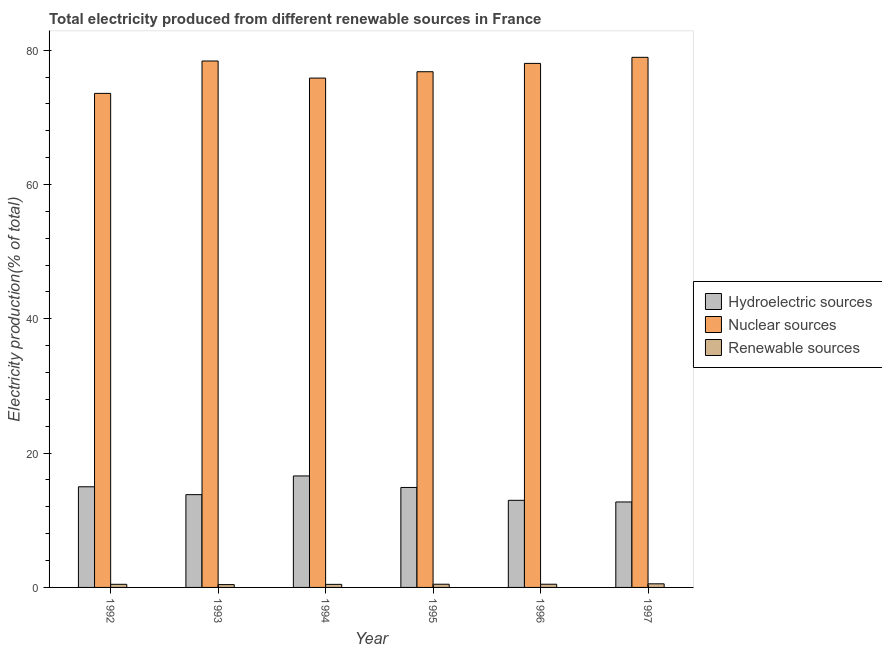How many different coloured bars are there?
Offer a terse response. 3. Are the number of bars per tick equal to the number of legend labels?
Make the answer very short. Yes. Are the number of bars on each tick of the X-axis equal?
Ensure brevity in your answer.  Yes. How many bars are there on the 1st tick from the left?
Ensure brevity in your answer.  3. How many bars are there on the 2nd tick from the right?
Provide a short and direct response. 3. What is the label of the 3rd group of bars from the left?
Offer a terse response. 1994. In how many cases, is the number of bars for a given year not equal to the number of legend labels?
Your response must be concise. 0. What is the percentage of electricity produced by renewable sources in 1992?
Keep it short and to the point. 0.46. Across all years, what is the maximum percentage of electricity produced by hydroelectric sources?
Your answer should be very brief. 16.6. Across all years, what is the minimum percentage of electricity produced by renewable sources?
Provide a short and direct response. 0.42. In which year was the percentage of electricity produced by renewable sources maximum?
Your answer should be very brief. 1997. What is the total percentage of electricity produced by hydroelectric sources in the graph?
Give a very brief answer. 85.99. What is the difference between the percentage of electricity produced by renewable sources in 1993 and that in 1995?
Keep it short and to the point. -0.05. What is the difference between the percentage of electricity produced by renewable sources in 1997 and the percentage of electricity produced by nuclear sources in 1994?
Your answer should be compact. 0.08. What is the average percentage of electricity produced by hydroelectric sources per year?
Provide a succinct answer. 14.33. In the year 1994, what is the difference between the percentage of electricity produced by nuclear sources and percentage of electricity produced by renewable sources?
Give a very brief answer. 0. What is the ratio of the percentage of electricity produced by nuclear sources in 1993 to that in 1994?
Offer a very short reply. 1.03. Is the percentage of electricity produced by nuclear sources in 1992 less than that in 1997?
Offer a terse response. Yes. Is the difference between the percentage of electricity produced by renewable sources in 1992 and 1996 greater than the difference between the percentage of electricity produced by nuclear sources in 1992 and 1996?
Provide a short and direct response. No. What is the difference between the highest and the second highest percentage of electricity produced by hydroelectric sources?
Your response must be concise. 1.61. What is the difference between the highest and the lowest percentage of electricity produced by nuclear sources?
Your response must be concise. 5.37. In how many years, is the percentage of electricity produced by nuclear sources greater than the average percentage of electricity produced by nuclear sources taken over all years?
Offer a terse response. 3. Is the sum of the percentage of electricity produced by renewable sources in 1994 and 1997 greater than the maximum percentage of electricity produced by hydroelectric sources across all years?
Ensure brevity in your answer.  Yes. What does the 3rd bar from the left in 1992 represents?
Offer a very short reply. Renewable sources. What does the 1st bar from the right in 1995 represents?
Ensure brevity in your answer.  Renewable sources. How many years are there in the graph?
Provide a succinct answer. 6. Are the values on the major ticks of Y-axis written in scientific E-notation?
Provide a succinct answer. No. Does the graph contain any zero values?
Give a very brief answer. No. Does the graph contain grids?
Your answer should be compact. No. How are the legend labels stacked?
Provide a succinct answer. Vertical. What is the title of the graph?
Ensure brevity in your answer.  Total electricity produced from different renewable sources in France. Does "Methane" appear as one of the legend labels in the graph?
Provide a short and direct response. No. What is the label or title of the X-axis?
Keep it short and to the point. Year. What is the Electricity production(% of total) of Hydroelectric sources in 1992?
Ensure brevity in your answer.  14.99. What is the Electricity production(% of total) of Nuclear sources in 1992?
Make the answer very short. 73.57. What is the Electricity production(% of total) in Renewable sources in 1992?
Your answer should be compact. 0.46. What is the Electricity production(% of total) of Hydroelectric sources in 1993?
Provide a succinct answer. 13.82. What is the Electricity production(% of total) of Nuclear sources in 1993?
Provide a short and direct response. 78.4. What is the Electricity production(% of total) of Renewable sources in 1993?
Your answer should be compact. 0.42. What is the Electricity production(% of total) in Hydroelectric sources in 1994?
Your answer should be very brief. 16.6. What is the Electricity production(% of total) of Nuclear sources in 1994?
Give a very brief answer. 75.85. What is the Electricity production(% of total) in Renewable sources in 1994?
Offer a very short reply. 0.46. What is the Electricity production(% of total) of Hydroelectric sources in 1995?
Ensure brevity in your answer.  14.89. What is the Electricity production(% of total) in Nuclear sources in 1995?
Make the answer very short. 76.8. What is the Electricity production(% of total) of Renewable sources in 1995?
Provide a short and direct response. 0.48. What is the Electricity production(% of total) of Hydroelectric sources in 1996?
Provide a short and direct response. 12.97. What is the Electricity production(% of total) of Nuclear sources in 1996?
Keep it short and to the point. 78.04. What is the Electricity production(% of total) in Renewable sources in 1996?
Keep it short and to the point. 0.48. What is the Electricity production(% of total) in Hydroelectric sources in 1997?
Provide a succinct answer. 12.73. What is the Electricity production(% of total) of Nuclear sources in 1997?
Keep it short and to the point. 78.94. What is the Electricity production(% of total) in Renewable sources in 1997?
Your response must be concise. 0.54. Across all years, what is the maximum Electricity production(% of total) of Hydroelectric sources?
Ensure brevity in your answer.  16.6. Across all years, what is the maximum Electricity production(% of total) in Nuclear sources?
Make the answer very short. 78.94. Across all years, what is the maximum Electricity production(% of total) in Renewable sources?
Ensure brevity in your answer.  0.54. Across all years, what is the minimum Electricity production(% of total) in Hydroelectric sources?
Provide a succinct answer. 12.73. Across all years, what is the minimum Electricity production(% of total) of Nuclear sources?
Your answer should be compact. 73.57. Across all years, what is the minimum Electricity production(% of total) in Renewable sources?
Your answer should be very brief. 0.42. What is the total Electricity production(% of total) of Hydroelectric sources in the graph?
Your answer should be very brief. 86. What is the total Electricity production(% of total) in Nuclear sources in the graph?
Your answer should be compact. 461.6. What is the total Electricity production(% of total) in Renewable sources in the graph?
Your response must be concise. 2.83. What is the difference between the Electricity production(% of total) in Hydroelectric sources in 1992 and that in 1993?
Ensure brevity in your answer.  1.17. What is the difference between the Electricity production(% of total) in Nuclear sources in 1992 and that in 1993?
Your response must be concise. -4.82. What is the difference between the Electricity production(% of total) in Renewable sources in 1992 and that in 1993?
Your answer should be very brief. 0.04. What is the difference between the Electricity production(% of total) of Hydroelectric sources in 1992 and that in 1994?
Ensure brevity in your answer.  -1.61. What is the difference between the Electricity production(% of total) of Nuclear sources in 1992 and that in 1994?
Give a very brief answer. -2.28. What is the difference between the Electricity production(% of total) of Renewable sources in 1992 and that in 1994?
Provide a short and direct response. 0.01. What is the difference between the Electricity production(% of total) of Hydroelectric sources in 1992 and that in 1995?
Ensure brevity in your answer.  0.1. What is the difference between the Electricity production(% of total) in Nuclear sources in 1992 and that in 1995?
Provide a short and direct response. -3.22. What is the difference between the Electricity production(% of total) of Renewable sources in 1992 and that in 1995?
Your answer should be very brief. -0.01. What is the difference between the Electricity production(% of total) in Hydroelectric sources in 1992 and that in 1996?
Offer a very short reply. 2.02. What is the difference between the Electricity production(% of total) in Nuclear sources in 1992 and that in 1996?
Provide a short and direct response. -4.47. What is the difference between the Electricity production(% of total) of Renewable sources in 1992 and that in 1996?
Ensure brevity in your answer.  -0.01. What is the difference between the Electricity production(% of total) in Hydroelectric sources in 1992 and that in 1997?
Ensure brevity in your answer.  2.26. What is the difference between the Electricity production(% of total) in Nuclear sources in 1992 and that in 1997?
Your answer should be compact. -5.37. What is the difference between the Electricity production(% of total) of Renewable sources in 1992 and that in 1997?
Your answer should be compact. -0.07. What is the difference between the Electricity production(% of total) of Hydroelectric sources in 1993 and that in 1994?
Make the answer very short. -2.78. What is the difference between the Electricity production(% of total) of Nuclear sources in 1993 and that in 1994?
Your response must be concise. 2.55. What is the difference between the Electricity production(% of total) of Renewable sources in 1993 and that in 1994?
Make the answer very short. -0.04. What is the difference between the Electricity production(% of total) of Hydroelectric sources in 1993 and that in 1995?
Make the answer very short. -1.07. What is the difference between the Electricity production(% of total) in Nuclear sources in 1993 and that in 1995?
Offer a terse response. 1.6. What is the difference between the Electricity production(% of total) in Renewable sources in 1993 and that in 1995?
Your response must be concise. -0.05. What is the difference between the Electricity production(% of total) in Hydroelectric sources in 1993 and that in 1996?
Ensure brevity in your answer.  0.85. What is the difference between the Electricity production(% of total) of Nuclear sources in 1993 and that in 1996?
Keep it short and to the point. 0.36. What is the difference between the Electricity production(% of total) of Renewable sources in 1993 and that in 1996?
Keep it short and to the point. -0.06. What is the difference between the Electricity production(% of total) in Hydroelectric sources in 1993 and that in 1997?
Keep it short and to the point. 1.09. What is the difference between the Electricity production(% of total) in Nuclear sources in 1993 and that in 1997?
Your response must be concise. -0.55. What is the difference between the Electricity production(% of total) in Renewable sources in 1993 and that in 1997?
Give a very brief answer. -0.12. What is the difference between the Electricity production(% of total) of Hydroelectric sources in 1994 and that in 1995?
Offer a terse response. 1.72. What is the difference between the Electricity production(% of total) in Nuclear sources in 1994 and that in 1995?
Your response must be concise. -0.95. What is the difference between the Electricity production(% of total) in Renewable sources in 1994 and that in 1995?
Offer a terse response. -0.02. What is the difference between the Electricity production(% of total) in Hydroelectric sources in 1994 and that in 1996?
Give a very brief answer. 3.63. What is the difference between the Electricity production(% of total) of Nuclear sources in 1994 and that in 1996?
Offer a terse response. -2.19. What is the difference between the Electricity production(% of total) of Renewable sources in 1994 and that in 1996?
Keep it short and to the point. -0.02. What is the difference between the Electricity production(% of total) in Hydroelectric sources in 1994 and that in 1997?
Your answer should be compact. 3.87. What is the difference between the Electricity production(% of total) in Nuclear sources in 1994 and that in 1997?
Your response must be concise. -3.09. What is the difference between the Electricity production(% of total) in Renewable sources in 1994 and that in 1997?
Keep it short and to the point. -0.08. What is the difference between the Electricity production(% of total) in Hydroelectric sources in 1995 and that in 1996?
Offer a terse response. 1.91. What is the difference between the Electricity production(% of total) of Nuclear sources in 1995 and that in 1996?
Your answer should be compact. -1.24. What is the difference between the Electricity production(% of total) in Renewable sources in 1995 and that in 1996?
Give a very brief answer. -0. What is the difference between the Electricity production(% of total) of Hydroelectric sources in 1995 and that in 1997?
Provide a succinct answer. 2.16. What is the difference between the Electricity production(% of total) of Nuclear sources in 1995 and that in 1997?
Give a very brief answer. -2.14. What is the difference between the Electricity production(% of total) of Renewable sources in 1995 and that in 1997?
Keep it short and to the point. -0.06. What is the difference between the Electricity production(% of total) of Hydroelectric sources in 1996 and that in 1997?
Offer a very short reply. 0.24. What is the difference between the Electricity production(% of total) in Nuclear sources in 1996 and that in 1997?
Provide a short and direct response. -0.9. What is the difference between the Electricity production(% of total) of Renewable sources in 1996 and that in 1997?
Offer a very short reply. -0.06. What is the difference between the Electricity production(% of total) of Hydroelectric sources in 1992 and the Electricity production(% of total) of Nuclear sources in 1993?
Your response must be concise. -63.41. What is the difference between the Electricity production(% of total) of Hydroelectric sources in 1992 and the Electricity production(% of total) of Renewable sources in 1993?
Offer a very short reply. 14.57. What is the difference between the Electricity production(% of total) of Nuclear sources in 1992 and the Electricity production(% of total) of Renewable sources in 1993?
Keep it short and to the point. 73.15. What is the difference between the Electricity production(% of total) of Hydroelectric sources in 1992 and the Electricity production(% of total) of Nuclear sources in 1994?
Your answer should be very brief. -60.86. What is the difference between the Electricity production(% of total) of Hydroelectric sources in 1992 and the Electricity production(% of total) of Renewable sources in 1994?
Give a very brief answer. 14.53. What is the difference between the Electricity production(% of total) of Nuclear sources in 1992 and the Electricity production(% of total) of Renewable sources in 1994?
Offer a very short reply. 73.12. What is the difference between the Electricity production(% of total) of Hydroelectric sources in 1992 and the Electricity production(% of total) of Nuclear sources in 1995?
Offer a very short reply. -61.81. What is the difference between the Electricity production(% of total) in Hydroelectric sources in 1992 and the Electricity production(% of total) in Renewable sources in 1995?
Keep it short and to the point. 14.51. What is the difference between the Electricity production(% of total) in Nuclear sources in 1992 and the Electricity production(% of total) in Renewable sources in 1995?
Provide a succinct answer. 73.1. What is the difference between the Electricity production(% of total) in Hydroelectric sources in 1992 and the Electricity production(% of total) in Nuclear sources in 1996?
Provide a succinct answer. -63.05. What is the difference between the Electricity production(% of total) in Hydroelectric sources in 1992 and the Electricity production(% of total) in Renewable sources in 1996?
Your response must be concise. 14.51. What is the difference between the Electricity production(% of total) in Nuclear sources in 1992 and the Electricity production(% of total) in Renewable sources in 1996?
Make the answer very short. 73.1. What is the difference between the Electricity production(% of total) of Hydroelectric sources in 1992 and the Electricity production(% of total) of Nuclear sources in 1997?
Make the answer very short. -63.95. What is the difference between the Electricity production(% of total) in Hydroelectric sources in 1992 and the Electricity production(% of total) in Renewable sources in 1997?
Offer a terse response. 14.45. What is the difference between the Electricity production(% of total) of Nuclear sources in 1992 and the Electricity production(% of total) of Renewable sources in 1997?
Keep it short and to the point. 73.04. What is the difference between the Electricity production(% of total) of Hydroelectric sources in 1993 and the Electricity production(% of total) of Nuclear sources in 1994?
Your answer should be compact. -62.03. What is the difference between the Electricity production(% of total) in Hydroelectric sources in 1993 and the Electricity production(% of total) in Renewable sources in 1994?
Provide a short and direct response. 13.36. What is the difference between the Electricity production(% of total) in Nuclear sources in 1993 and the Electricity production(% of total) in Renewable sources in 1994?
Provide a short and direct response. 77.94. What is the difference between the Electricity production(% of total) in Hydroelectric sources in 1993 and the Electricity production(% of total) in Nuclear sources in 1995?
Provide a short and direct response. -62.98. What is the difference between the Electricity production(% of total) in Hydroelectric sources in 1993 and the Electricity production(% of total) in Renewable sources in 1995?
Keep it short and to the point. 13.34. What is the difference between the Electricity production(% of total) in Nuclear sources in 1993 and the Electricity production(% of total) in Renewable sources in 1995?
Offer a terse response. 77.92. What is the difference between the Electricity production(% of total) of Hydroelectric sources in 1993 and the Electricity production(% of total) of Nuclear sources in 1996?
Your answer should be very brief. -64.22. What is the difference between the Electricity production(% of total) in Hydroelectric sources in 1993 and the Electricity production(% of total) in Renewable sources in 1996?
Your answer should be compact. 13.34. What is the difference between the Electricity production(% of total) in Nuclear sources in 1993 and the Electricity production(% of total) in Renewable sources in 1996?
Offer a very short reply. 77.92. What is the difference between the Electricity production(% of total) of Hydroelectric sources in 1993 and the Electricity production(% of total) of Nuclear sources in 1997?
Offer a very short reply. -65.12. What is the difference between the Electricity production(% of total) of Hydroelectric sources in 1993 and the Electricity production(% of total) of Renewable sources in 1997?
Provide a succinct answer. 13.28. What is the difference between the Electricity production(% of total) of Nuclear sources in 1993 and the Electricity production(% of total) of Renewable sources in 1997?
Give a very brief answer. 77.86. What is the difference between the Electricity production(% of total) of Hydroelectric sources in 1994 and the Electricity production(% of total) of Nuclear sources in 1995?
Keep it short and to the point. -60.2. What is the difference between the Electricity production(% of total) of Hydroelectric sources in 1994 and the Electricity production(% of total) of Renewable sources in 1995?
Your answer should be compact. 16.13. What is the difference between the Electricity production(% of total) in Nuclear sources in 1994 and the Electricity production(% of total) in Renewable sources in 1995?
Your response must be concise. 75.38. What is the difference between the Electricity production(% of total) in Hydroelectric sources in 1994 and the Electricity production(% of total) in Nuclear sources in 1996?
Your response must be concise. -61.44. What is the difference between the Electricity production(% of total) of Hydroelectric sources in 1994 and the Electricity production(% of total) of Renewable sources in 1996?
Your response must be concise. 16.12. What is the difference between the Electricity production(% of total) in Nuclear sources in 1994 and the Electricity production(% of total) in Renewable sources in 1996?
Provide a short and direct response. 75.37. What is the difference between the Electricity production(% of total) of Hydroelectric sources in 1994 and the Electricity production(% of total) of Nuclear sources in 1997?
Offer a terse response. -62.34. What is the difference between the Electricity production(% of total) of Hydroelectric sources in 1994 and the Electricity production(% of total) of Renewable sources in 1997?
Keep it short and to the point. 16.07. What is the difference between the Electricity production(% of total) in Nuclear sources in 1994 and the Electricity production(% of total) in Renewable sources in 1997?
Your answer should be compact. 75.31. What is the difference between the Electricity production(% of total) in Hydroelectric sources in 1995 and the Electricity production(% of total) in Nuclear sources in 1996?
Your answer should be compact. -63.15. What is the difference between the Electricity production(% of total) of Hydroelectric sources in 1995 and the Electricity production(% of total) of Renewable sources in 1996?
Provide a short and direct response. 14.41. What is the difference between the Electricity production(% of total) of Nuclear sources in 1995 and the Electricity production(% of total) of Renewable sources in 1996?
Keep it short and to the point. 76.32. What is the difference between the Electricity production(% of total) of Hydroelectric sources in 1995 and the Electricity production(% of total) of Nuclear sources in 1997?
Offer a terse response. -64.06. What is the difference between the Electricity production(% of total) of Hydroelectric sources in 1995 and the Electricity production(% of total) of Renewable sources in 1997?
Give a very brief answer. 14.35. What is the difference between the Electricity production(% of total) in Nuclear sources in 1995 and the Electricity production(% of total) in Renewable sources in 1997?
Provide a succinct answer. 76.26. What is the difference between the Electricity production(% of total) of Hydroelectric sources in 1996 and the Electricity production(% of total) of Nuclear sources in 1997?
Ensure brevity in your answer.  -65.97. What is the difference between the Electricity production(% of total) in Hydroelectric sources in 1996 and the Electricity production(% of total) in Renewable sources in 1997?
Provide a succinct answer. 12.43. What is the difference between the Electricity production(% of total) in Nuclear sources in 1996 and the Electricity production(% of total) in Renewable sources in 1997?
Provide a short and direct response. 77.5. What is the average Electricity production(% of total) of Hydroelectric sources per year?
Give a very brief answer. 14.33. What is the average Electricity production(% of total) in Nuclear sources per year?
Provide a short and direct response. 76.93. What is the average Electricity production(% of total) in Renewable sources per year?
Provide a succinct answer. 0.47. In the year 1992, what is the difference between the Electricity production(% of total) in Hydroelectric sources and Electricity production(% of total) in Nuclear sources?
Your answer should be very brief. -58.58. In the year 1992, what is the difference between the Electricity production(% of total) of Hydroelectric sources and Electricity production(% of total) of Renewable sources?
Make the answer very short. 14.53. In the year 1992, what is the difference between the Electricity production(% of total) of Nuclear sources and Electricity production(% of total) of Renewable sources?
Provide a succinct answer. 73.11. In the year 1993, what is the difference between the Electricity production(% of total) of Hydroelectric sources and Electricity production(% of total) of Nuclear sources?
Provide a succinct answer. -64.58. In the year 1993, what is the difference between the Electricity production(% of total) in Hydroelectric sources and Electricity production(% of total) in Renewable sources?
Offer a very short reply. 13.4. In the year 1993, what is the difference between the Electricity production(% of total) of Nuclear sources and Electricity production(% of total) of Renewable sources?
Offer a very short reply. 77.97. In the year 1994, what is the difference between the Electricity production(% of total) of Hydroelectric sources and Electricity production(% of total) of Nuclear sources?
Your answer should be very brief. -59.25. In the year 1994, what is the difference between the Electricity production(% of total) of Hydroelectric sources and Electricity production(% of total) of Renewable sources?
Offer a very short reply. 16.15. In the year 1994, what is the difference between the Electricity production(% of total) of Nuclear sources and Electricity production(% of total) of Renewable sources?
Your answer should be compact. 75.39. In the year 1995, what is the difference between the Electricity production(% of total) in Hydroelectric sources and Electricity production(% of total) in Nuclear sources?
Offer a terse response. -61.91. In the year 1995, what is the difference between the Electricity production(% of total) of Hydroelectric sources and Electricity production(% of total) of Renewable sources?
Make the answer very short. 14.41. In the year 1995, what is the difference between the Electricity production(% of total) of Nuclear sources and Electricity production(% of total) of Renewable sources?
Keep it short and to the point. 76.32. In the year 1996, what is the difference between the Electricity production(% of total) of Hydroelectric sources and Electricity production(% of total) of Nuclear sources?
Your answer should be compact. -65.07. In the year 1996, what is the difference between the Electricity production(% of total) in Hydroelectric sources and Electricity production(% of total) in Renewable sources?
Offer a terse response. 12.49. In the year 1996, what is the difference between the Electricity production(% of total) in Nuclear sources and Electricity production(% of total) in Renewable sources?
Provide a short and direct response. 77.56. In the year 1997, what is the difference between the Electricity production(% of total) in Hydroelectric sources and Electricity production(% of total) in Nuclear sources?
Offer a very short reply. -66.21. In the year 1997, what is the difference between the Electricity production(% of total) of Hydroelectric sources and Electricity production(% of total) of Renewable sources?
Make the answer very short. 12.19. In the year 1997, what is the difference between the Electricity production(% of total) in Nuclear sources and Electricity production(% of total) in Renewable sources?
Give a very brief answer. 78.41. What is the ratio of the Electricity production(% of total) of Hydroelectric sources in 1992 to that in 1993?
Ensure brevity in your answer.  1.08. What is the ratio of the Electricity production(% of total) in Nuclear sources in 1992 to that in 1993?
Your answer should be compact. 0.94. What is the ratio of the Electricity production(% of total) in Renewable sources in 1992 to that in 1993?
Keep it short and to the point. 1.1. What is the ratio of the Electricity production(% of total) of Hydroelectric sources in 1992 to that in 1994?
Offer a very short reply. 0.9. What is the ratio of the Electricity production(% of total) of Renewable sources in 1992 to that in 1994?
Make the answer very short. 1.02. What is the ratio of the Electricity production(% of total) of Hydroelectric sources in 1992 to that in 1995?
Offer a terse response. 1.01. What is the ratio of the Electricity production(% of total) in Nuclear sources in 1992 to that in 1995?
Your answer should be very brief. 0.96. What is the ratio of the Electricity production(% of total) in Renewable sources in 1992 to that in 1995?
Ensure brevity in your answer.  0.98. What is the ratio of the Electricity production(% of total) in Hydroelectric sources in 1992 to that in 1996?
Your response must be concise. 1.16. What is the ratio of the Electricity production(% of total) of Nuclear sources in 1992 to that in 1996?
Provide a succinct answer. 0.94. What is the ratio of the Electricity production(% of total) in Renewable sources in 1992 to that in 1996?
Give a very brief answer. 0.97. What is the ratio of the Electricity production(% of total) of Hydroelectric sources in 1992 to that in 1997?
Your response must be concise. 1.18. What is the ratio of the Electricity production(% of total) in Nuclear sources in 1992 to that in 1997?
Keep it short and to the point. 0.93. What is the ratio of the Electricity production(% of total) of Renewable sources in 1992 to that in 1997?
Make the answer very short. 0.86. What is the ratio of the Electricity production(% of total) of Hydroelectric sources in 1993 to that in 1994?
Offer a terse response. 0.83. What is the ratio of the Electricity production(% of total) in Nuclear sources in 1993 to that in 1994?
Keep it short and to the point. 1.03. What is the ratio of the Electricity production(% of total) of Renewable sources in 1993 to that in 1994?
Give a very brief answer. 0.92. What is the ratio of the Electricity production(% of total) in Hydroelectric sources in 1993 to that in 1995?
Your answer should be compact. 0.93. What is the ratio of the Electricity production(% of total) of Nuclear sources in 1993 to that in 1995?
Provide a short and direct response. 1.02. What is the ratio of the Electricity production(% of total) in Renewable sources in 1993 to that in 1995?
Your answer should be compact. 0.89. What is the ratio of the Electricity production(% of total) in Hydroelectric sources in 1993 to that in 1996?
Ensure brevity in your answer.  1.07. What is the ratio of the Electricity production(% of total) of Renewable sources in 1993 to that in 1996?
Provide a short and direct response. 0.88. What is the ratio of the Electricity production(% of total) in Hydroelectric sources in 1993 to that in 1997?
Give a very brief answer. 1.09. What is the ratio of the Electricity production(% of total) of Nuclear sources in 1993 to that in 1997?
Ensure brevity in your answer.  0.99. What is the ratio of the Electricity production(% of total) in Renewable sources in 1993 to that in 1997?
Offer a terse response. 0.78. What is the ratio of the Electricity production(% of total) of Hydroelectric sources in 1994 to that in 1995?
Your answer should be very brief. 1.12. What is the ratio of the Electricity production(% of total) of Renewable sources in 1994 to that in 1995?
Your response must be concise. 0.96. What is the ratio of the Electricity production(% of total) in Hydroelectric sources in 1994 to that in 1996?
Offer a very short reply. 1.28. What is the ratio of the Electricity production(% of total) of Nuclear sources in 1994 to that in 1996?
Your answer should be very brief. 0.97. What is the ratio of the Electricity production(% of total) in Renewable sources in 1994 to that in 1996?
Provide a short and direct response. 0.95. What is the ratio of the Electricity production(% of total) in Hydroelectric sources in 1994 to that in 1997?
Provide a short and direct response. 1.3. What is the ratio of the Electricity production(% of total) in Nuclear sources in 1994 to that in 1997?
Offer a very short reply. 0.96. What is the ratio of the Electricity production(% of total) of Renewable sources in 1994 to that in 1997?
Ensure brevity in your answer.  0.85. What is the ratio of the Electricity production(% of total) in Hydroelectric sources in 1995 to that in 1996?
Offer a terse response. 1.15. What is the ratio of the Electricity production(% of total) in Nuclear sources in 1995 to that in 1996?
Your answer should be very brief. 0.98. What is the ratio of the Electricity production(% of total) in Renewable sources in 1995 to that in 1996?
Offer a terse response. 1. What is the ratio of the Electricity production(% of total) in Hydroelectric sources in 1995 to that in 1997?
Make the answer very short. 1.17. What is the ratio of the Electricity production(% of total) in Nuclear sources in 1995 to that in 1997?
Make the answer very short. 0.97. What is the ratio of the Electricity production(% of total) in Renewable sources in 1995 to that in 1997?
Offer a terse response. 0.89. What is the ratio of the Electricity production(% of total) in Hydroelectric sources in 1996 to that in 1997?
Offer a very short reply. 1.02. What is the ratio of the Electricity production(% of total) of Renewable sources in 1996 to that in 1997?
Your response must be concise. 0.89. What is the difference between the highest and the second highest Electricity production(% of total) in Hydroelectric sources?
Make the answer very short. 1.61. What is the difference between the highest and the second highest Electricity production(% of total) of Nuclear sources?
Provide a succinct answer. 0.55. What is the difference between the highest and the second highest Electricity production(% of total) of Renewable sources?
Make the answer very short. 0.06. What is the difference between the highest and the lowest Electricity production(% of total) of Hydroelectric sources?
Your answer should be compact. 3.87. What is the difference between the highest and the lowest Electricity production(% of total) in Nuclear sources?
Ensure brevity in your answer.  5.37. What is the difference between the highest and the lowest Electricity production(% of total) in Renewable sources?
Provide a short and direct response. 0.12. 